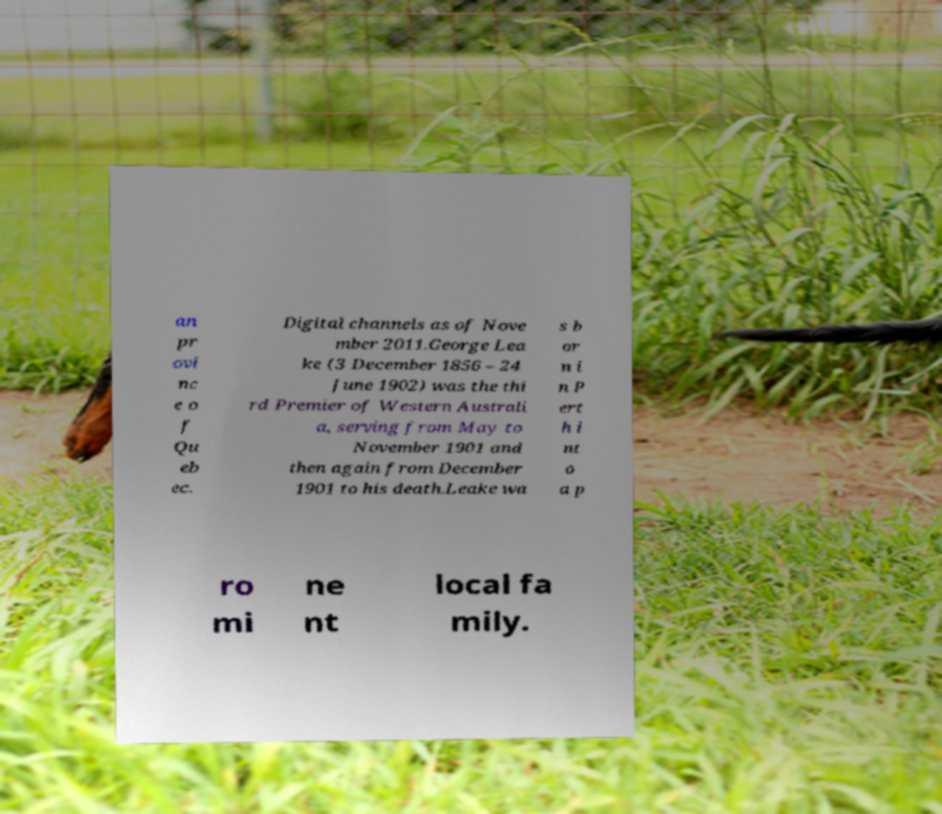Could you assist in decoding the text presented in this image and type it out clearly? an pr ovi nc e o f Qu eb ec. Digital channels as of Nove mber 2011.George Lea ke (3 December 1856 – 24 June 1902) was the thi rd Premier of Western Australi a, serving from May to November 1901 and then again from December 1901 to his death.Leake wa s b or n i n P ert h i nt o a p ro mi ne nt local fa mily. 